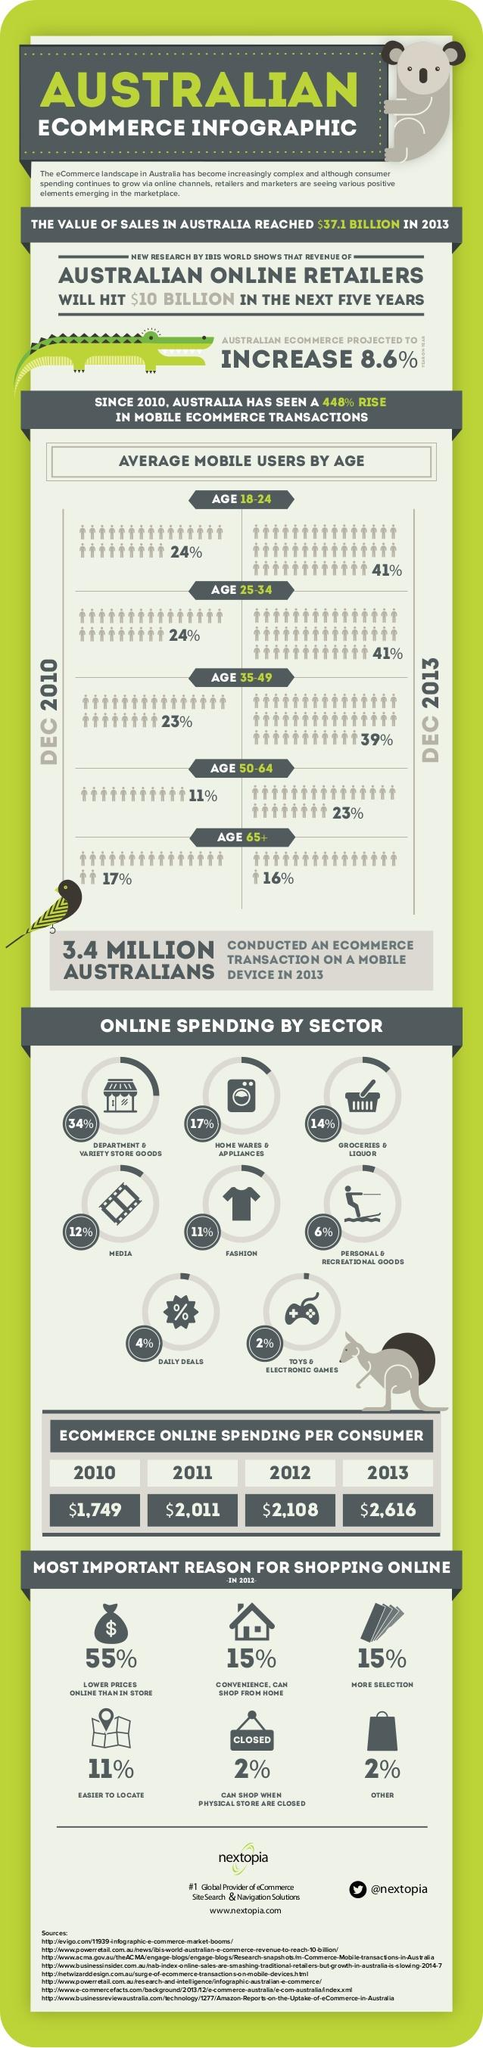Indicate a few pertinent items in this graphic. According to recent statistics, a significant portion, approximately 17%, of online spending in Australia is dedicated to home wares and appliances. In December 2013, it was determined that 16% of the average mobile users in Australia were in the age group of 65 years and older. According to data, only 6% of online spending in Australia is done by personal and recreational goods. The amount of ecommerce online spending per consumer in Australia in the year 2012 was approximately $2,108. In the year 2011, the average amount of ecommerce spending per consumer in Australia was $2,011. 